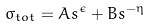<formula> <loc_0><loc_0><loc_500><loc_500>\sigma _ { t o t } = A s ^ { \epsilon } + B s ^ { - \eta }</formula> 